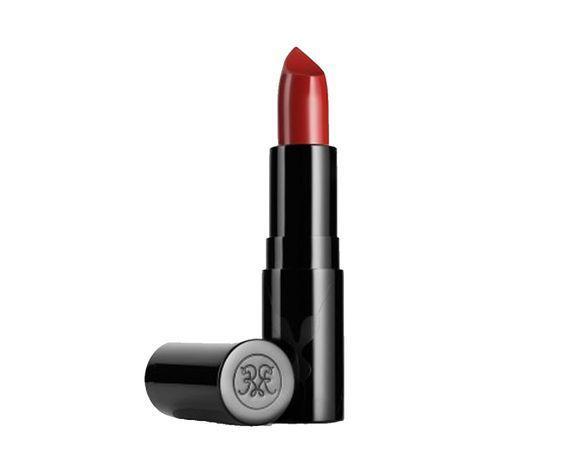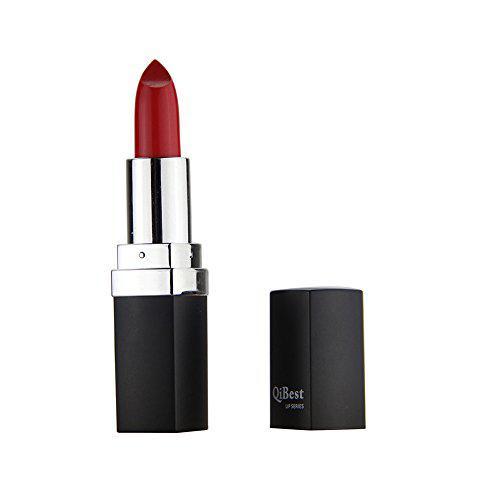The first image is the image on the left, the second image is the image on the right. For the images displayed, is the sentence "An image shows an upright solid black tube of red lipstick with its black cylindrical cap alongside it." factually correct? Answer yes or no. Yes. The first image is the image on the left, the second image is the image on the right. Evaluate the accuracy of this statement regarding the images: "One open tube of lipstick is black with a visible logo somewhere on the tube, and the black cap laying sideways beside it.". Is it true? Answer yes or no. Yes. 